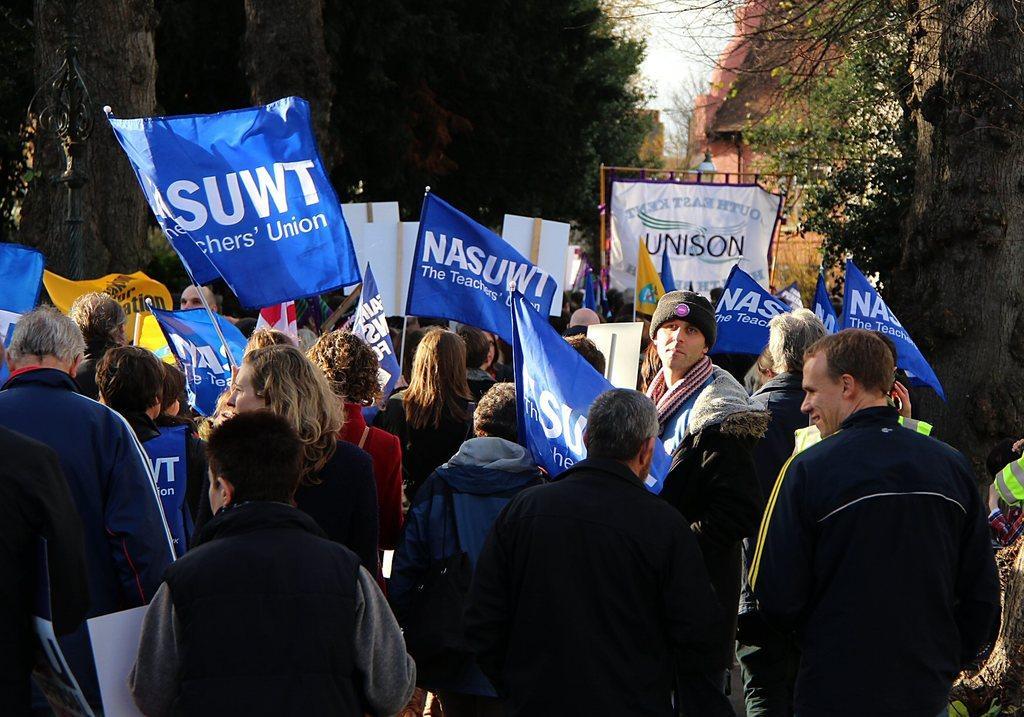Describe this image in one or two sentences. In this picture I can see group of people standing and holding placards and flags, and in the background there are trees and a building. 